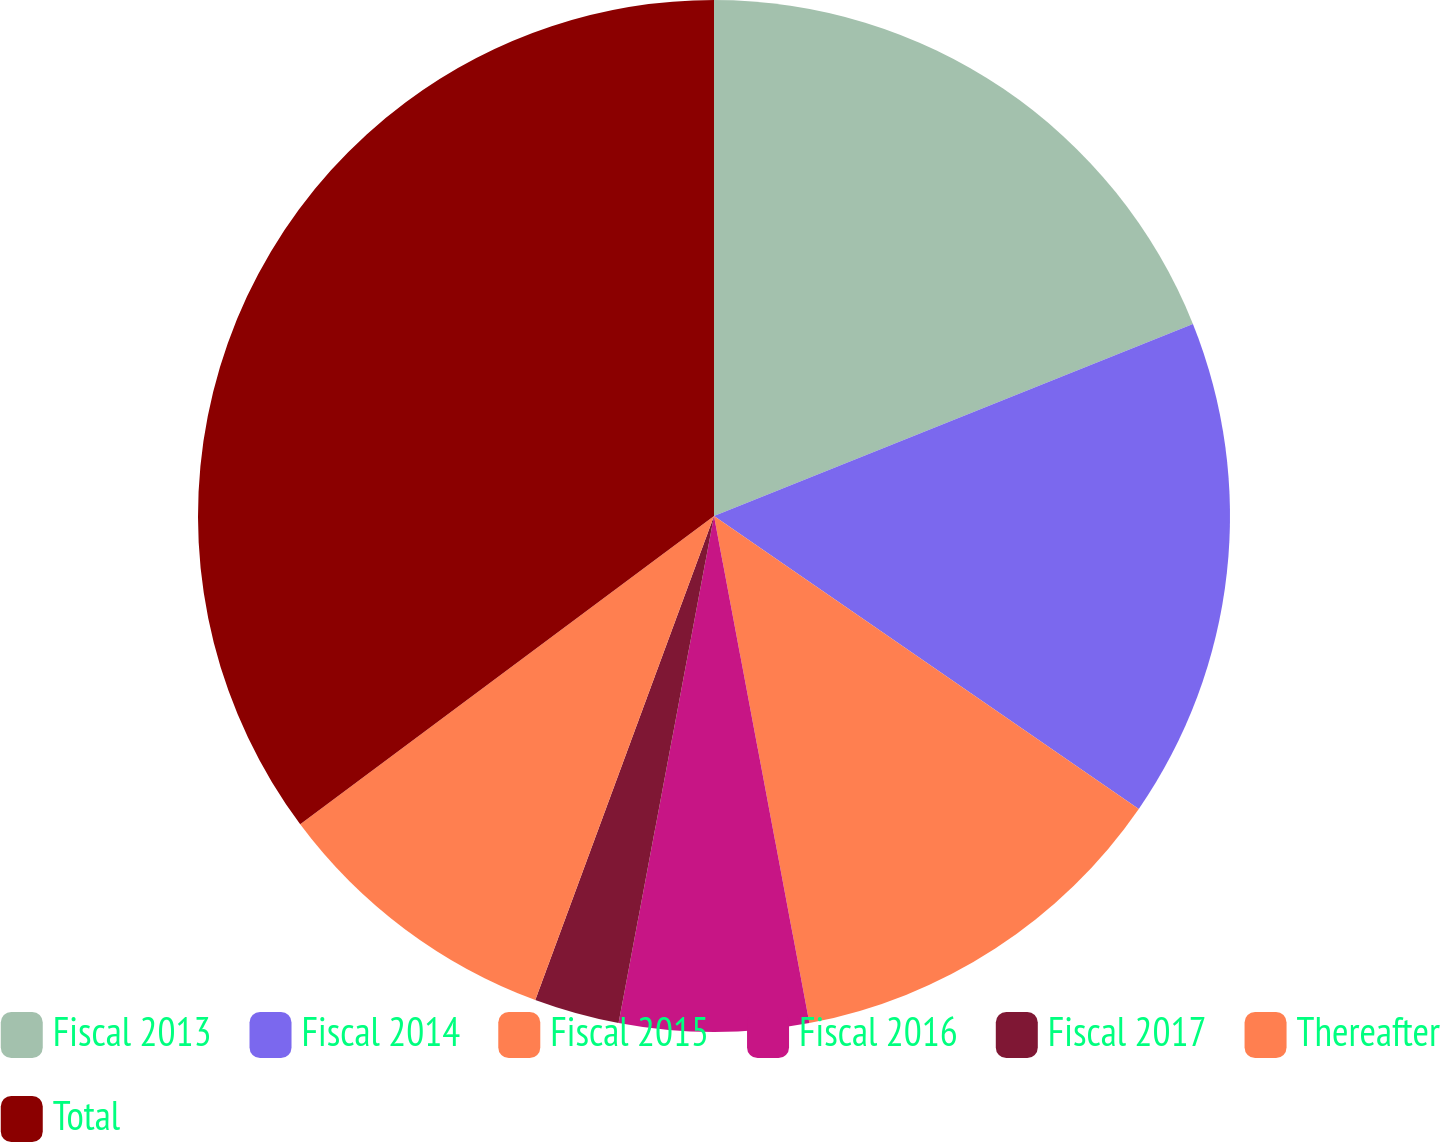Convert chart. <chart><loc_0><loc_0><loc_500><loc_500><pie_chart><fcel>Fiscal 2013<fcel>Fiscal 2014<fcel>Fiscal 2015<fcel>Fiscal 2016<fcel>Fiscal 2017<fcel>Thereafter<fcel>Total<nl><fcel>18.93%<fcel>15.68%<fcel>12.43%<fcel>5.92%<fcel>2.67%<fcel>9.18%<fcel>35.19%<nl></chart> 